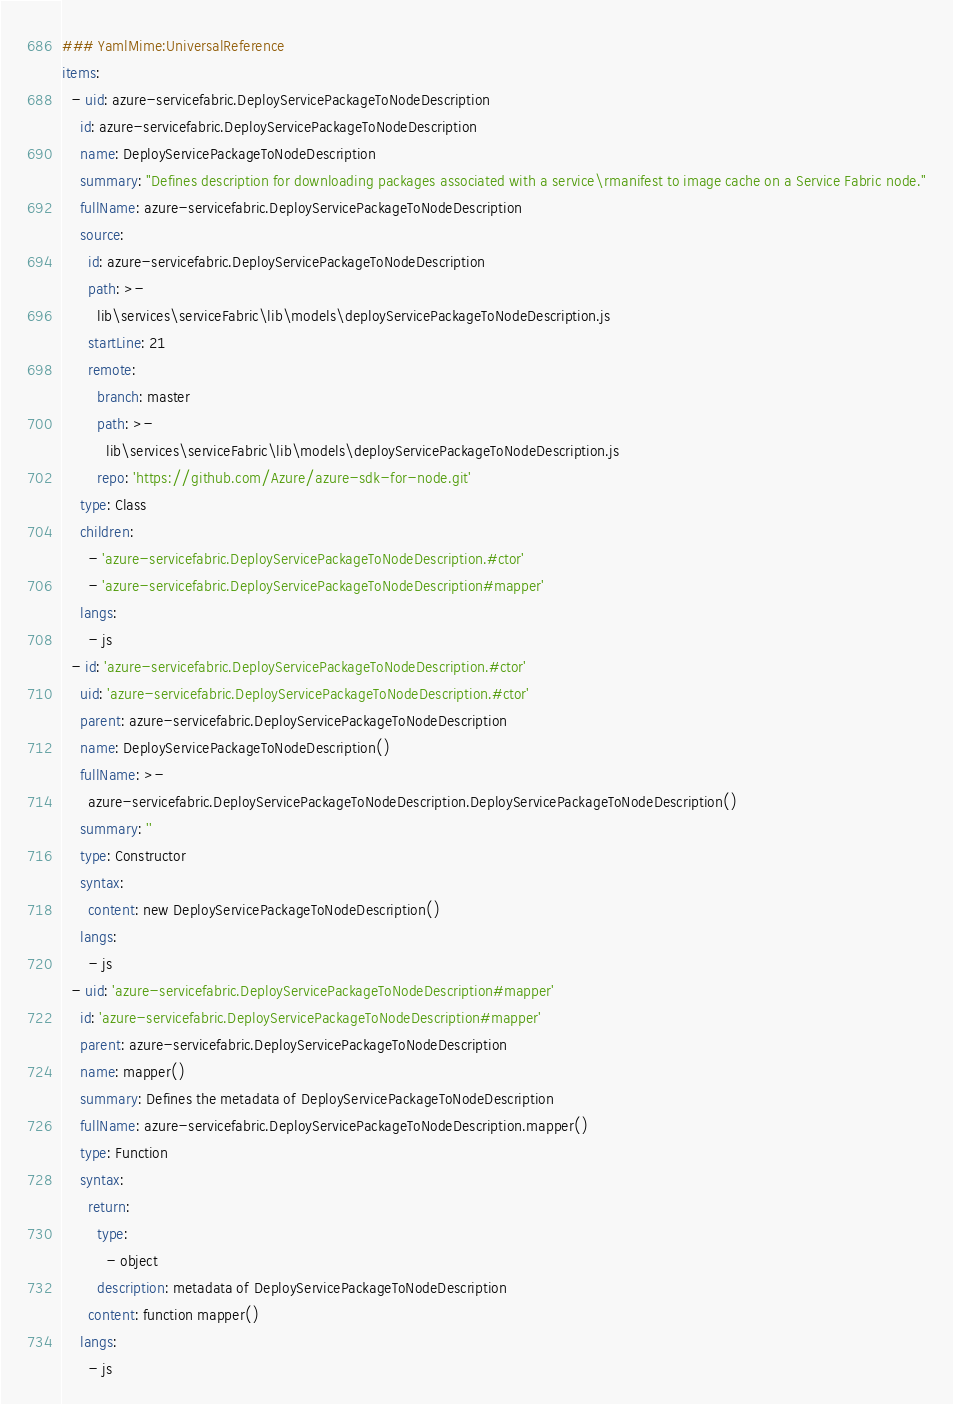<code> <loc_0><loc_0><loc_500><loc_500><_YAML_>### YamlMime:UniversalReference
items:
  - uid: azure-servicefabric.DeployServicePackageToNodeDescription
    id: azure-servicefabric.DeployServicePackageToNodeDescription
    name: DeployServicePackageToNodeDescription
    summary: "Defines description for downloading packages associated with a service\rmanifest to image cache on a Service Fabric node."
    fullName: azure-servicefabric.DeployServicePackageToNodeDescription
    source:
      id: azure-servicefabric.DeployServicePackageToNodeDescription
      path: >-
        lib\services\serviceFabric\lib\models\deployServicePackageToNodeDescription.js
      startLine: 21
      remote:
        branch: master
        path: >-
          lib\services\serviceFabric\lib\models\deployServicePackageToNodeDescription.js
        repo: 'https://github.com/Azure/azure-sdk-for-node.git'
    type: Class
    children:
      - 'azure-servicefabric.DeployServicePackageToNodeDescription.#ctor'
      - 'azure-servicefabric.DeployServicePackageToNodeDescription#mapper'
    langs:
      - js
  - id: 'azure-servicefabric.DeployServicePackageToNodeDescription.#ctor'
    uid: 'azure-servicefabric.DeployServicePackageToNodeDescription.#ctor'
    parent: azure-servicefabric.DeployServicePackageToNodeDescription
    name: DeployServicePackageToNodeDescription()
    fullName: >-
      azure-servicefabric.DeployServicePackageToNodeDescription.DeployServicePackageToNodeDescription()
    summary: ''
    type: Constructor
    syntax:
      content: new DeployServicePackageToNodeDescription()
    langs:
      - js
  - uid: 'azure-servicefabric.DeployServicePackageToNodeDescription#mapper'
    id: 'azure-servicefabric.DeployServicePackageToNodeDescription#mapper'
    parent: azure-servicefabric.DeployServicePackageToNodeDescription
    name: mapper()
    summary: Defines the metadata of DeployServicePackageToNodeDescription
    fullName: azure-servicefabric.DeployServicePackageToNodeDescription.mapper()
    type: Function
    syntax:
      return:
        type:
          - object
        description: metadata of DeployServicePackageToNodeDescription
      content: function mapper()
    langs:
      - js
</code> 